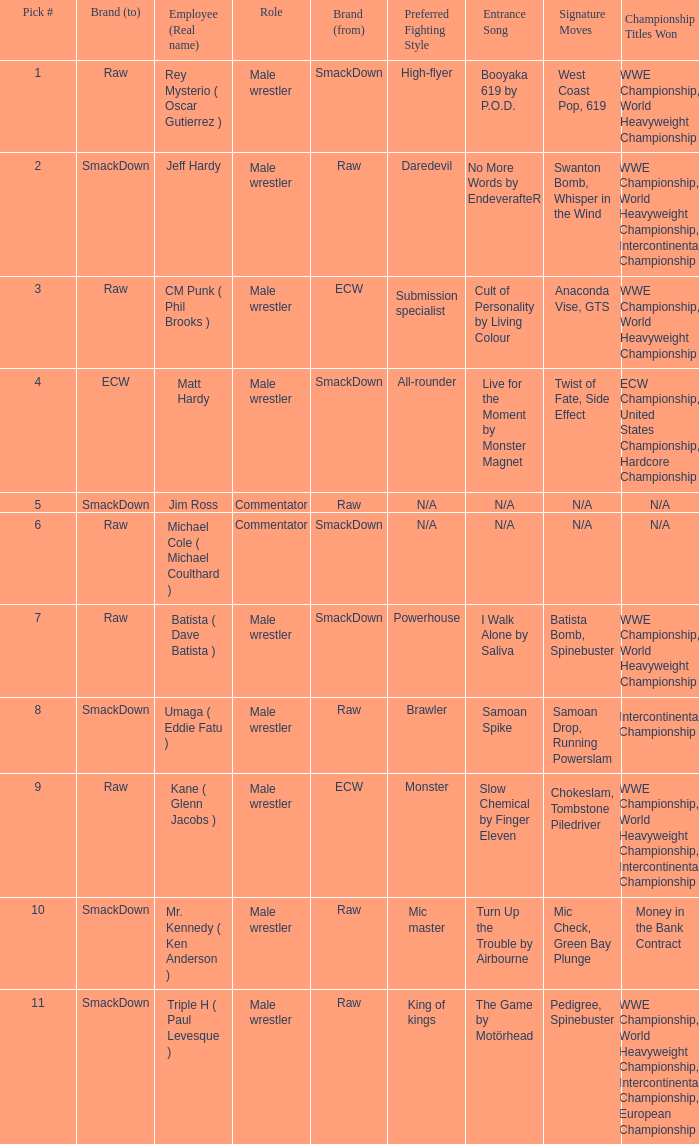Pick # 3 works for which brand? ECW. 